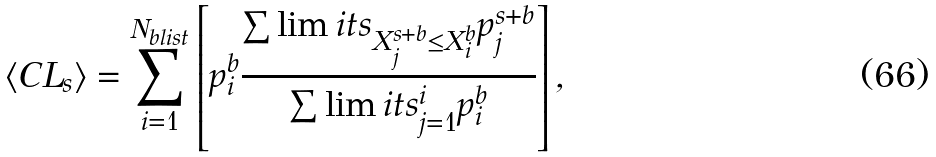Convert formula to latex. <formula><loc_0><loc_0><loc_500><loc_500>\langle C L _ { s } \rangle = \sum _ { i = 1 } ^ { N _ { b l i s t } } \left [ p _ { i } ^ { b } \frac { \sum \lim i t s _ { X _ { j } ^ { s + b } \leq X _ { i } ^ { b } } p _ { j } ^ { s + b } } { \sum \lim i t s _ { j = 1 } ^ { i } p _ { i } ^ { b } } \right ] ,</formula> 